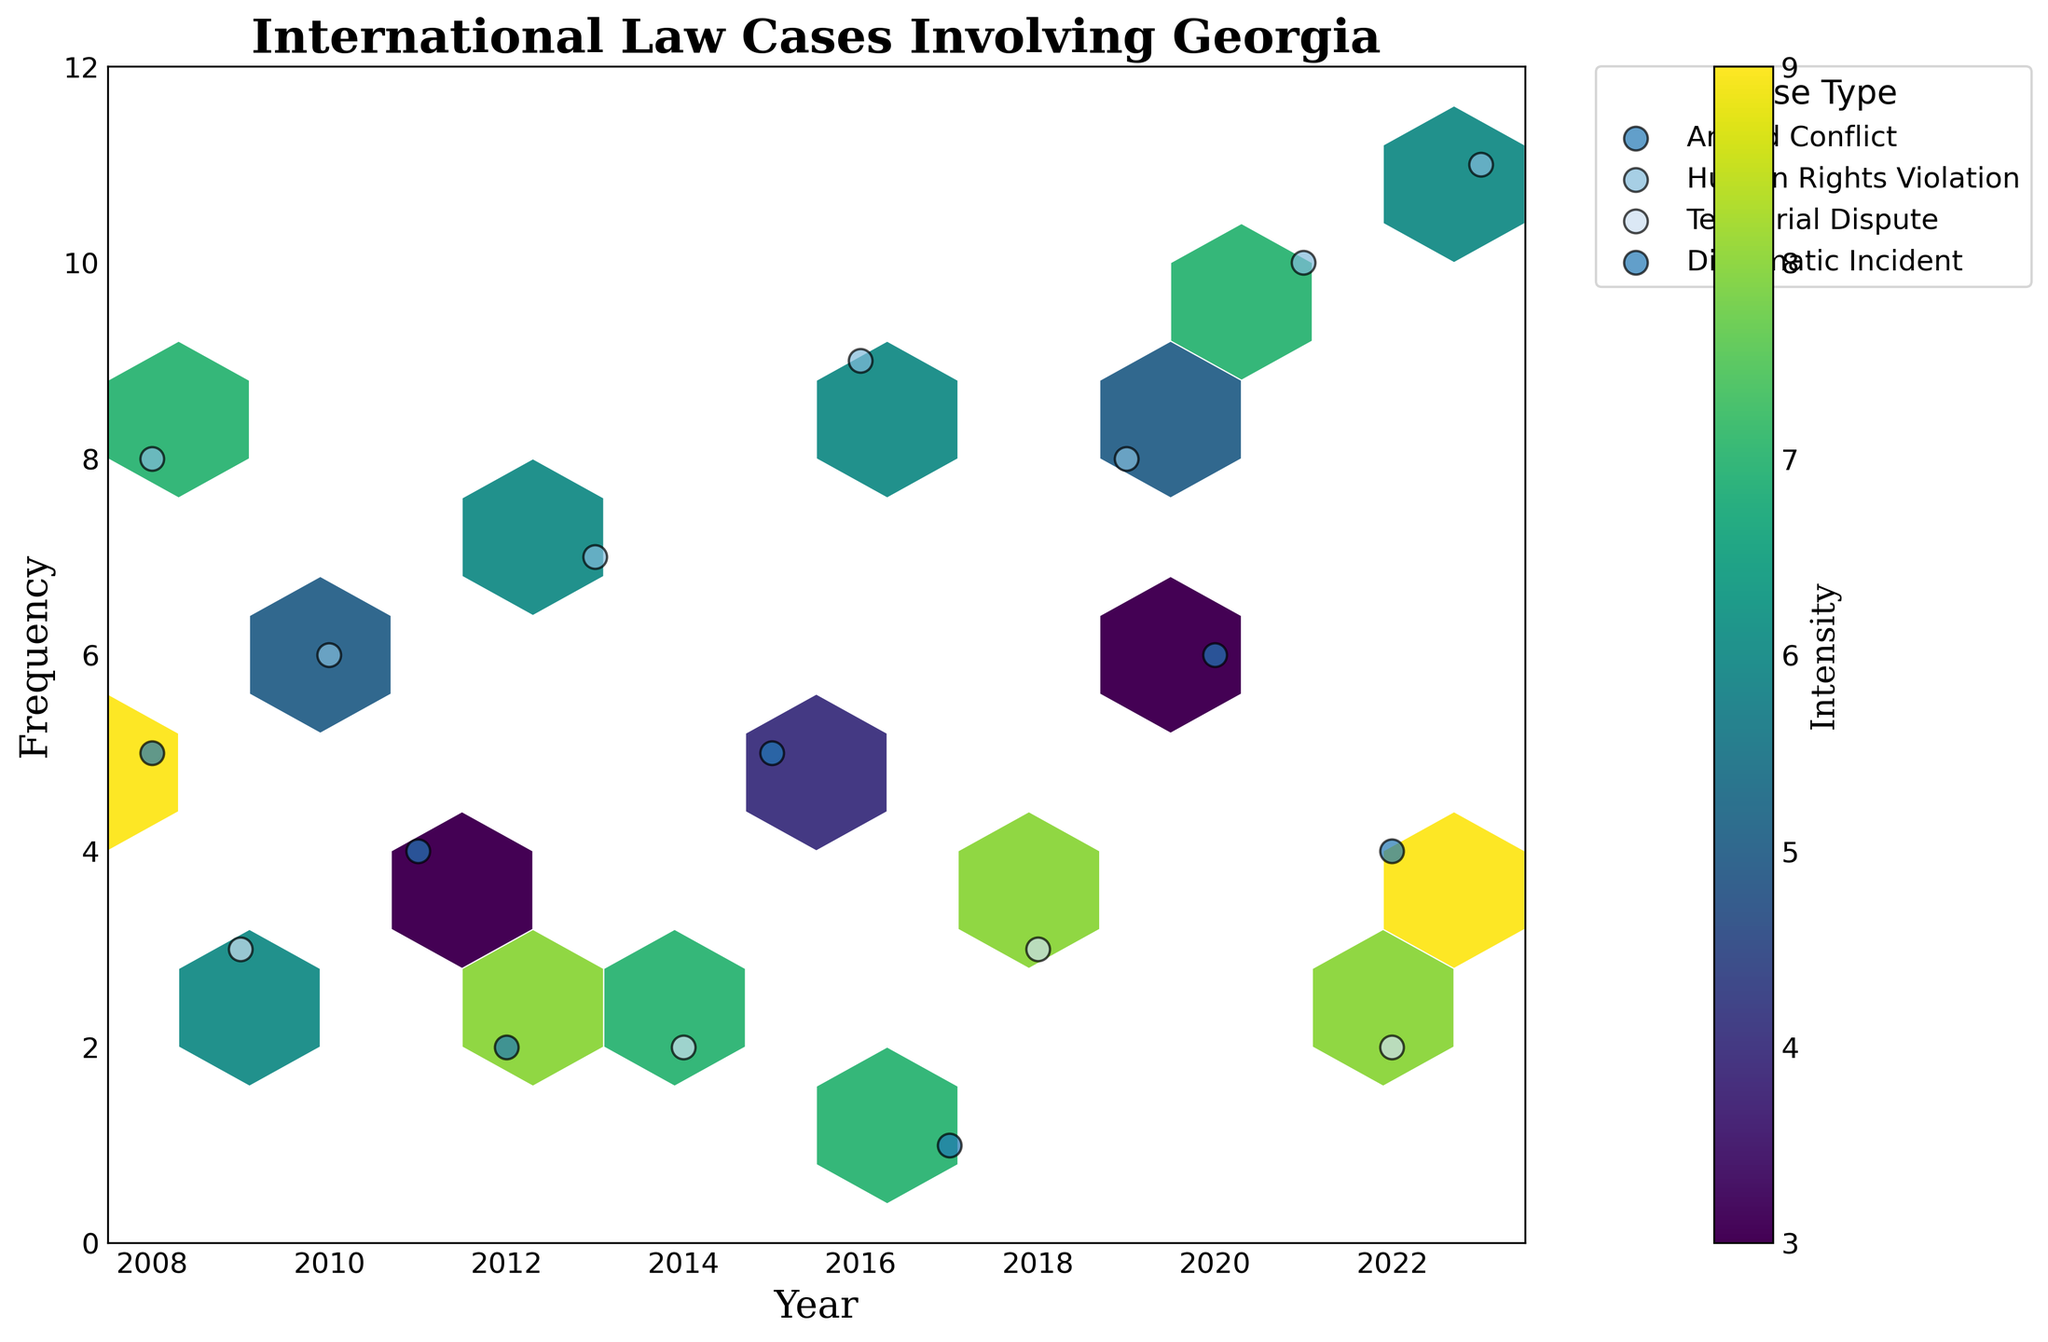what is the title of the plot? The title of the plot is clearly displayed at the top center of the figure, showing what the plot represents.
Answer: International Law Cases Involving Georgia what information is provided on the x-axis? By examining the x-axis labels at the bottom of the plot, we can identify the information it provides.
Answer: Year what case types have data points for the year 2022? The legend on the plot indicates different case types, and by matching these with the data points corresponding to 2022 on the x-axis, the case types can be identified.
Answer: Armed Conflict, Territorial Dispute how many Human Rights Violation cases are there in 2023 and what is their frequency? Locate the case type "Human Rights Violation" in the legend and trace its data points along the x-axis to the year 2023 to find the frequency value.
Answer: 11 cases, Frequency 11 which year had the highest frequency of Human Rights Violation cases? By focusing on the data points for "Human Rights Violation" across years from the x-axis and comparing their frequencies, the highest frequency can be determined.
Answer: 2023 what is the intensity range for Territorial Dispute cases? Examine the data points labeled as "Territorial Dispute" and observe the color gradient in the hexbin plot to understand the intensity range.
Answer: 6 to 8 compare the frequencies of Diplomatic Incident cases in 2011 and 2020. Which year had higher frequency? By looking at the data points for Diplomatic Incident in the legend and matching them to the years 2011 and 2020 on the x-axis, compare the frequencies.
Answer: 2020 had higher frequency on average, how frequent were Armed Conflict cases based on the years with available data points? Adding up the frequencies of Armed Conflict cases from the plot and dividing by the number of years they occurred gives the average frequency.
Answer: (5 + 2 + 1 + 4) / 4 = 3 which case type had its maximum intensity in 2022? Focus on the data points for the year 2022 and compare their color intensities to identify the case type with maximum intensity.
Answer: Armed Conflict 